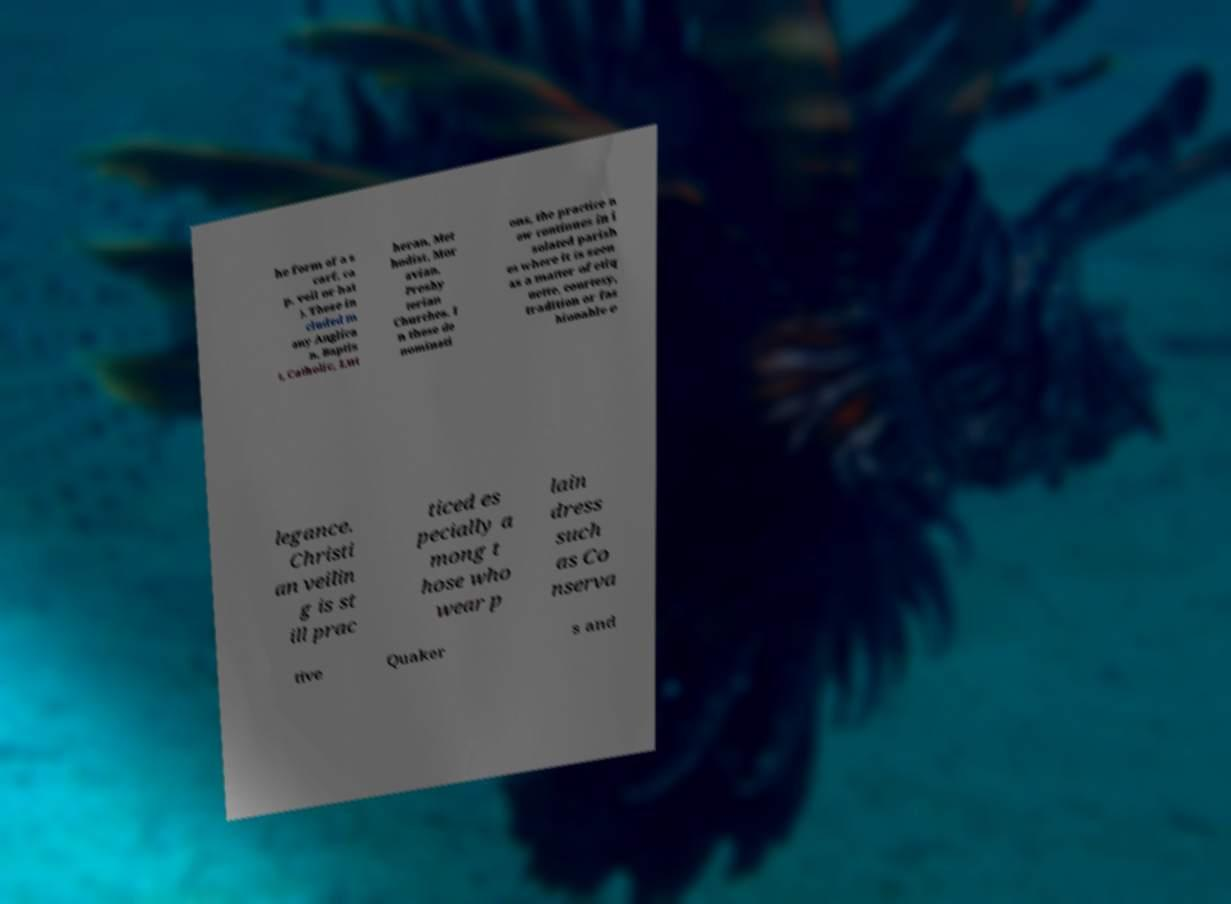Can you accurately transcribe the text from the provided image for me? he form of a s carf, ca p, veil or hat ). These in cluded m any Anglica n, Baptis t, Catholic, Lut heran, Met hodist, Mor avian, Presby terian Churches. I n these de nominati ons, the practice n ow continues in i solated parish es where it is seen as a matter of etiq uette, courtesy, tradition or fas hionable e legance. Christi an veilin g is st ill prac ticed es pecially a mong t hose who wear p lain dress such as Co nserva tive Quaker s and 